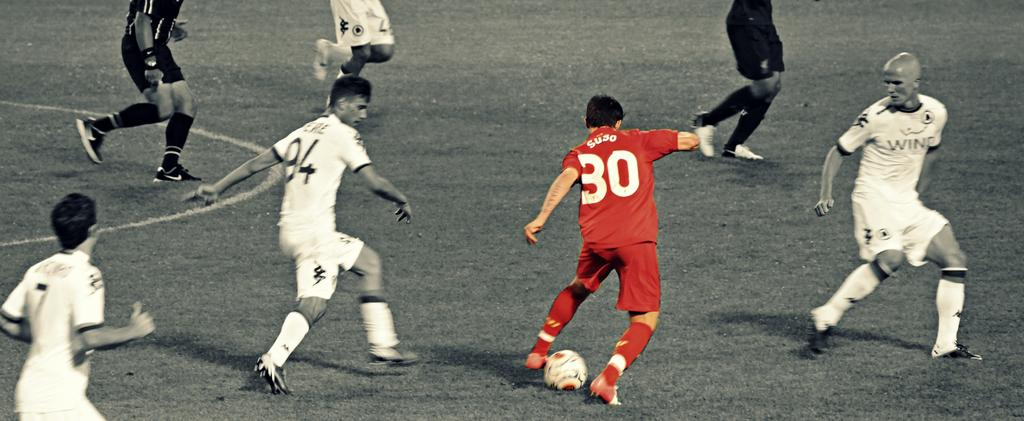What activity are the persons in the image engaged in? The persons in the image are playing football. Where is the football game taking place? The football game is taking place on a ground. What is the surface of the ground covered with? The ground is covered with grass. Can you see any kites flying in the image? There are no kites visible in the image; the focus is on the football game. 